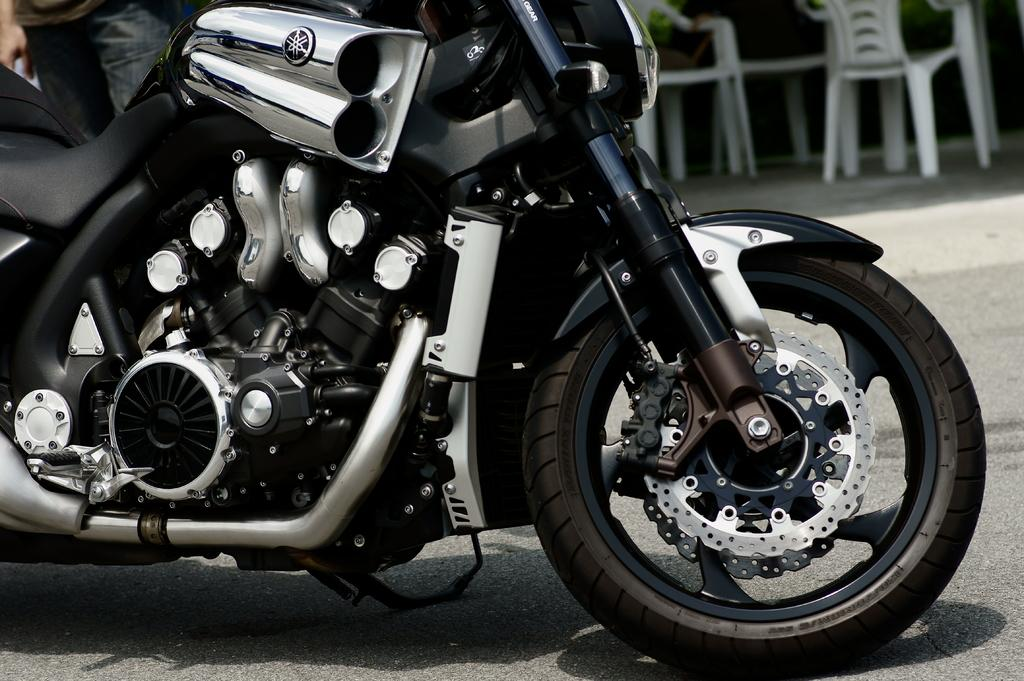What vehicle is present on the road in the image? There is a motorcycle on the road in the image. Who or what is near the motorcycle? A person is standing near the motorcycle. What type of furniture can be seen in the image? There are chairs in the image. What grade is the motorcycle in the image? The concept of a motorcycle being in a grade does not apply, as motorcycles are not graded like students or assignments. 